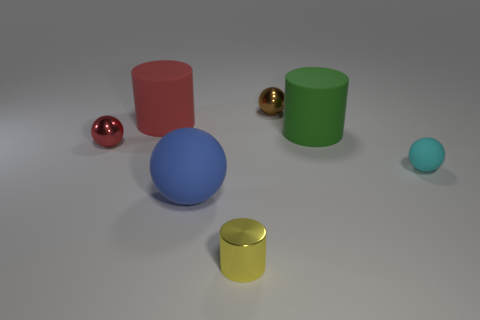Subtract all big cylinders. How many cylinders are left? 1 Subtract all balls. How many objects are left? 3 Subtract all gray spheres. How many blue cylinders are left? 0 Subtract all big green matte things. Subtract all tiny red metal balls. How many objects are left? 5 Add 6 green objects. How many green objects are left? 7 Add 3 cyan objects. How many cyan objects exist? 4 Add 1 big red matte cylinders. How many objects exist? 8 Subtract all green cylinders. How many cylinders are left? 2 Subtract 1 red spheres. How many objects are left? 6 Subtract all purple spheres. Subtract all cyan cylinders. How many spheres are left? 4 